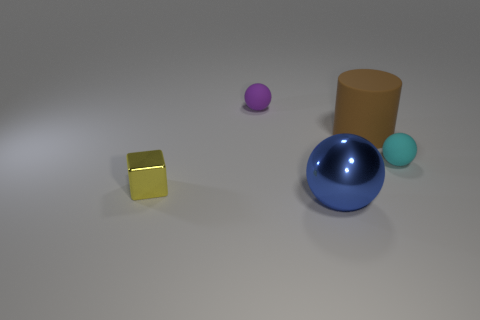Are there any tiny yellow objects made of the same material as the big blue ball? Yes, there is a tiny yellow cube on the left side of the image that appears to be made of the same shiny material as the big blue ball in the center. 